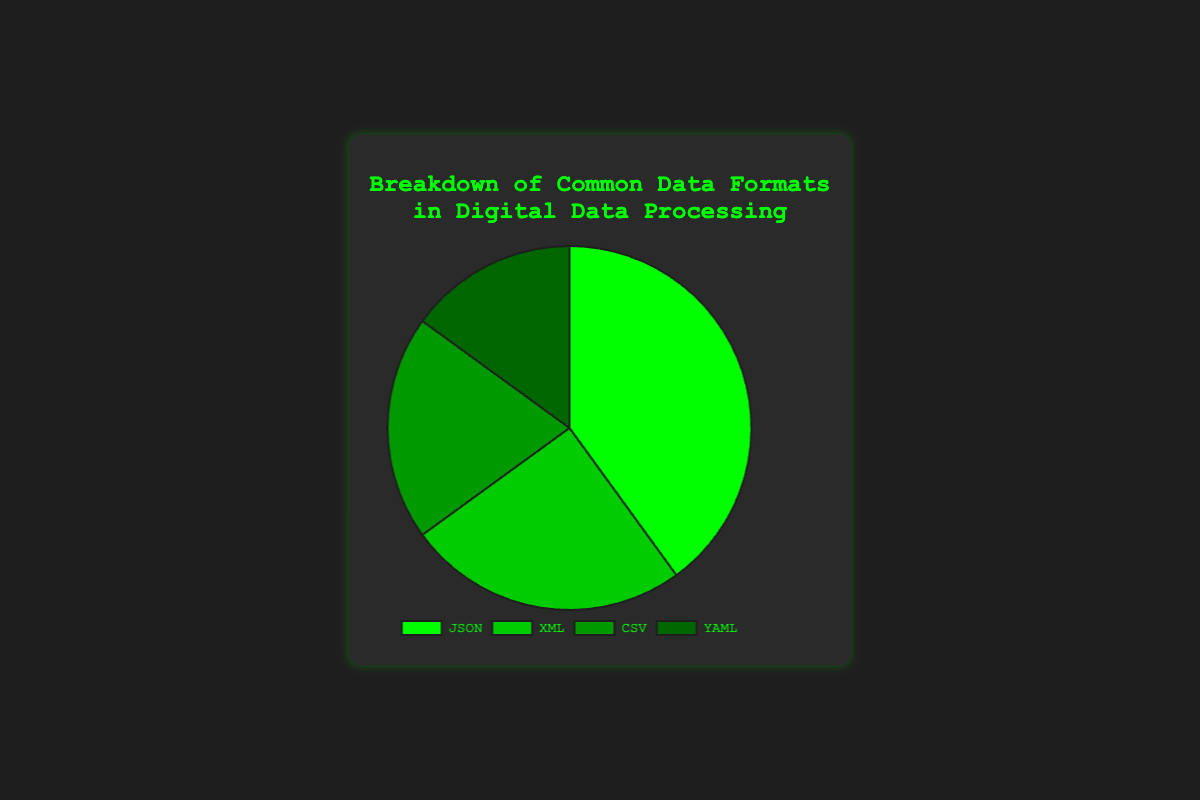What percentage of the total breakdown does XML and CSV together account for? To find the total percentage for XML and CSV, we add the percentages of both: 25% (XML) + 20% (CSV) = 45%.
Answer: 45% Is JSON used more frequently than YAML? By comparing the percentages, JSON (40%) has a higher percentage than YAML (15%).
Answer: Yes Which format has the smallest share in the pie chart? The smallest share is represented by comparing all given percentages (40%, 25%, 20%, 15%). YAML has the smallest percentage at 15%.
Answer: YAML What color represents the JSON segment in the pie chart? The color of each segment is visually identifiable. JSON is represented in green.
Answer: Green How much more percentage is JSON used compared to CSV? Subtract the percentage of CSV from the percentage of JSON: 40% (JSON) - 20% (CSV) = 20%.
Answer: 20% If you sum the usage percentages of the two least common formats, what do you get? The two least common formats are CSV (20%) and YAML (15%). Adding these gives 20% + 15% = 35%.
Answer: 35% How do XML and YAML usage combined compare to JSON usage? Add the percentages of XML and YAML then compare to JSON: 25% (XML) + 15% (YAML) = 40% which equals JSON's 40%.
Answer: Equal What is the percentage difference between the most and the least common data formats? Subtract the percentage of the least common format (YAML, 15%) from the most common format (JSON, 40%): 40% - 15% = 25%.
Answer: 25% Locate the segment that uses the darkest shade of green. Which format does it represent? The darkest shade of green corresponds to the lowest percentage, which is YAML at 15%.
Answer: YAML Which two data formats combined constitute exactly three-fifths of the total breakdown? We need to find two percentages that sum up to 60% (three-fifths of 100%). Adding XML (25%) and CSV (20%) equals 45%, but JSON (40%) combined with YAML (15%) sums to 55%. Therefore, adding JSON (40%) and CSV (20%) equals 60%.
Answer: JSON and CSV 